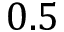Convert formula to latex. <formula><loc_0><loc_0><loc_500><loc_500>0 . 5</formula> 